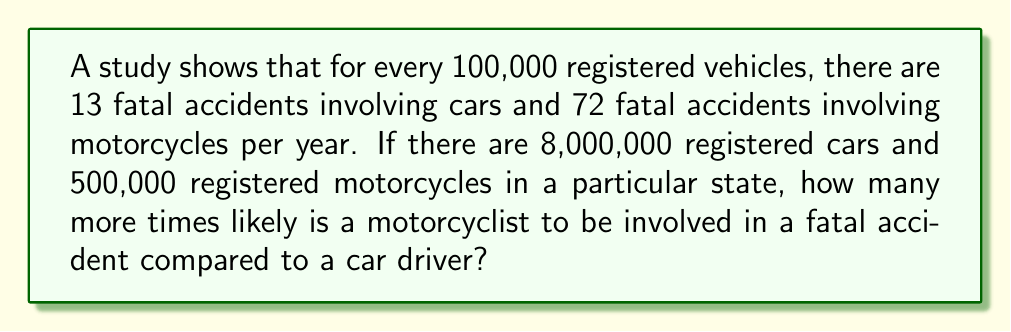Solve this math problem. Let's approach this step-by-step:

1) First, we need to calculate the number of fatal accidents for cars and motorcycles:

   For cars: 
   $$(13 \text{ accidents per 100,000 cars}) \times (8,000,000 \text{ cars}) \div (100,000)$$
   $$= 13 \times 80 = 1,040 \text{ fatal car accidents}$$

   For motorcycles:
   $$(72 \text{ accidents per 100,000 motorcycles}) \times (500,000 \text{ motorcycles}) \div (100,000)$$
   $$= 72 \times 5 = 360 \text{ fatal motorcycle accidents}$$

2) Now, we need to calculate the rate of fatal accidents per vehicle:

   For cars:
   $$\text{Rate}_{\text{car}} = \frac{1,040 \text{ accidents}}{8,000,000 \text{ cars}} = 0.00013 \text{ accidents per car}$$

   For motorcycles:
   $$\text{Rate}_{\text{motorcycle}} = \frac{360 \text{ accidents}}{500,000 \text{ motorcycles}} = 0.00072 \text{ accidents per motorcycle}$$

3) To find how many times more likely a motorcyclist is to be in a fatal accident, we divide the motorcycle rate by the car rate:

   $$\frac{\text{Rate}_{\text{motorcycle}}}{\text{Rate}_{\text{car}}} = \frac{0.00072}{0.00013} = 5.54$$

Therefore, a motorcyclist is about 5.54 times more likely to be involved in a fatal accident than a car driver.
Answer: 5.54 times 